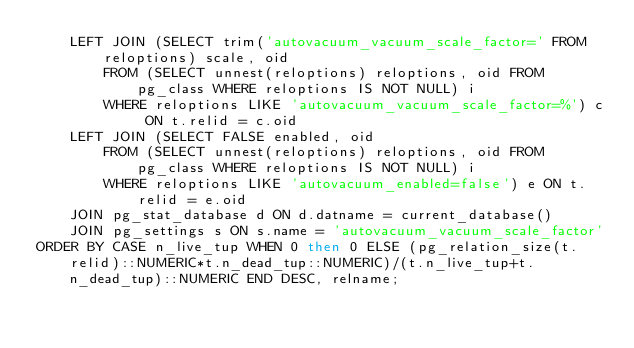<code> <loc_0><loc_0><loc_500><loc_500><_SQL_>    LEFT JOIN (SELECT trim('autovacuum_vacuum_scale_factor=' FROM reloptions) scale, oid
        FROM (SELECT unnest(reloptions) reloptions, oid FROM pg_class WHERE reloptions IS NOT NULL) i
        WHERE reloptions LIKE 'autovacuum_vacuum_scale_factor=%') c ON t.relid = c.oid
    LEFT JOIN (SELECT FALSE enabled, oid
        FROM (SELECT unnest(reloptions) reloptions, oid FROM pg_class WHERE reloptions IS NOT NULL) i
        WHERE reloptions LIKE 'autovacuum_enabled=false') e ON t.relid = e.oid
    JOIN pg_stat_database d ON d.datname = current_database()
    JOIN pg_settings s ON s.name = 'autovacuum_vacuum_scale_factor'
ORDER BY CASE n_live_tup WHEN 0 then 0 ELSE (pg_relation_size(t.relid)::NUMERIC*t.n_dead_tup::NUMERIC)/(t.n_live_tup+t.n_dead_tup)::NUMERIC END DESC, relname;</code> 